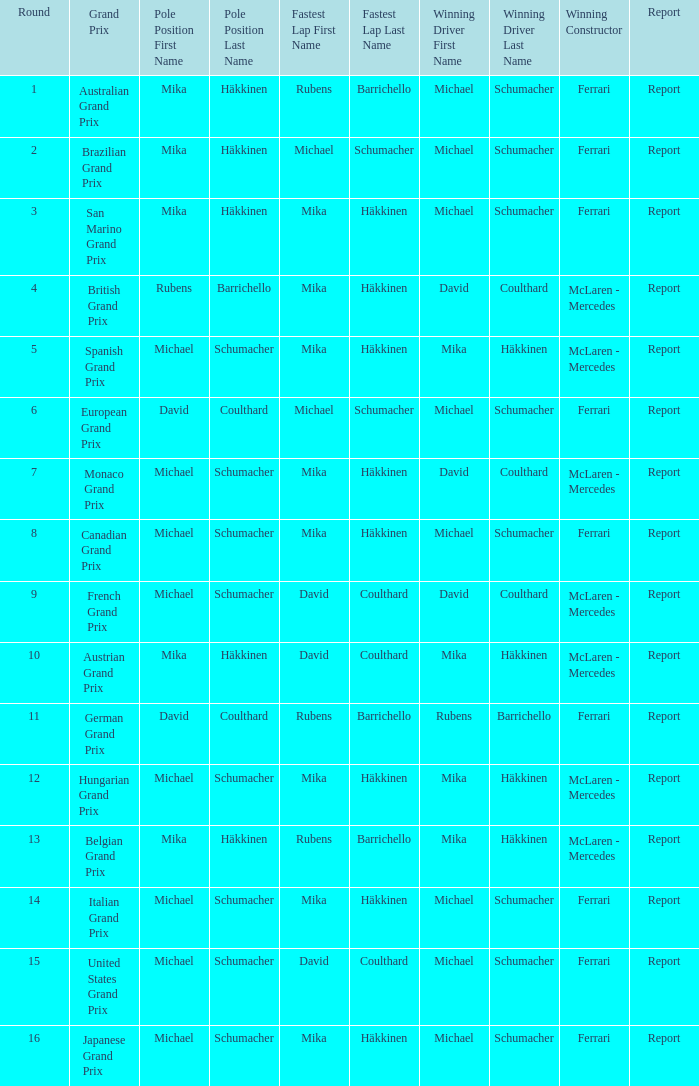What was the outcome of the belgian grand prix report? Report. 